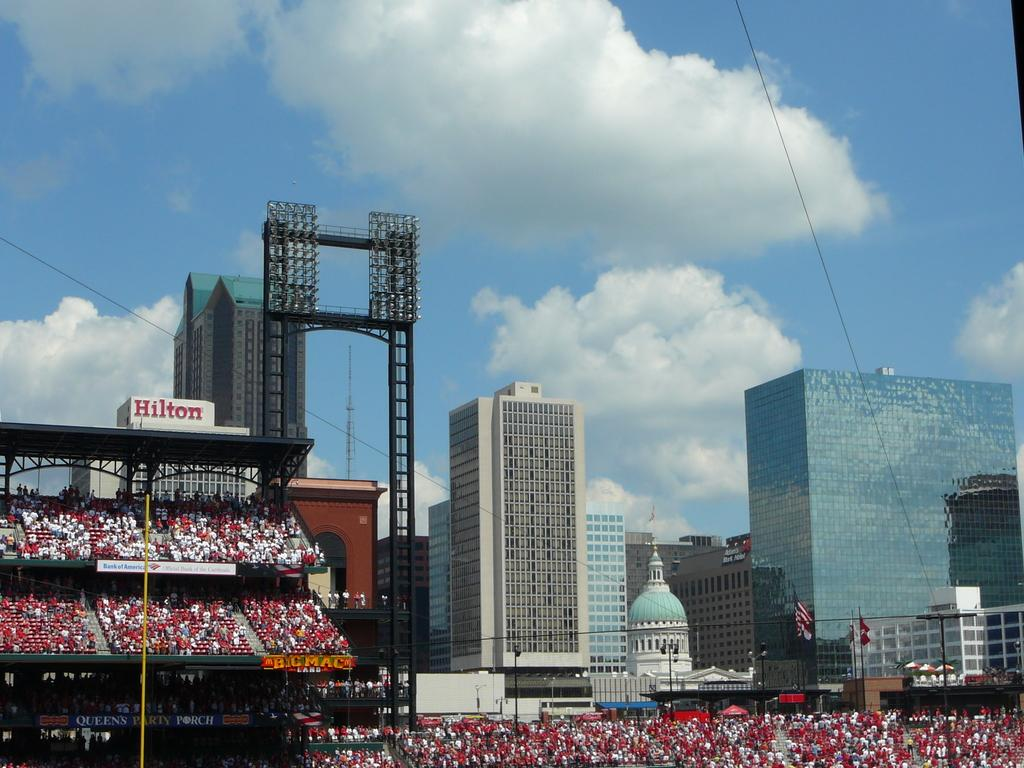What type of structure is the main subject of the image? There is a stadium in the image. Can you describe the people in the image? There is a group of people in the image. What can be seen in the image that provides illumination? There are lights and a lighting truss in the image. What other structures are visible in the image? There are buildings in the image. What type of decorative elements can be seen in the image? There are flags in the image. What is visible in the background of the image? The sky is visible in the background of the image. How does the floor of the stadium look like in the image? The image does not show the floor of the stadium; it only shows the exterior of the stadium. What is the group of people paying attention to in the image? The image does not show the group of people paying attention to any specific subject or object. 